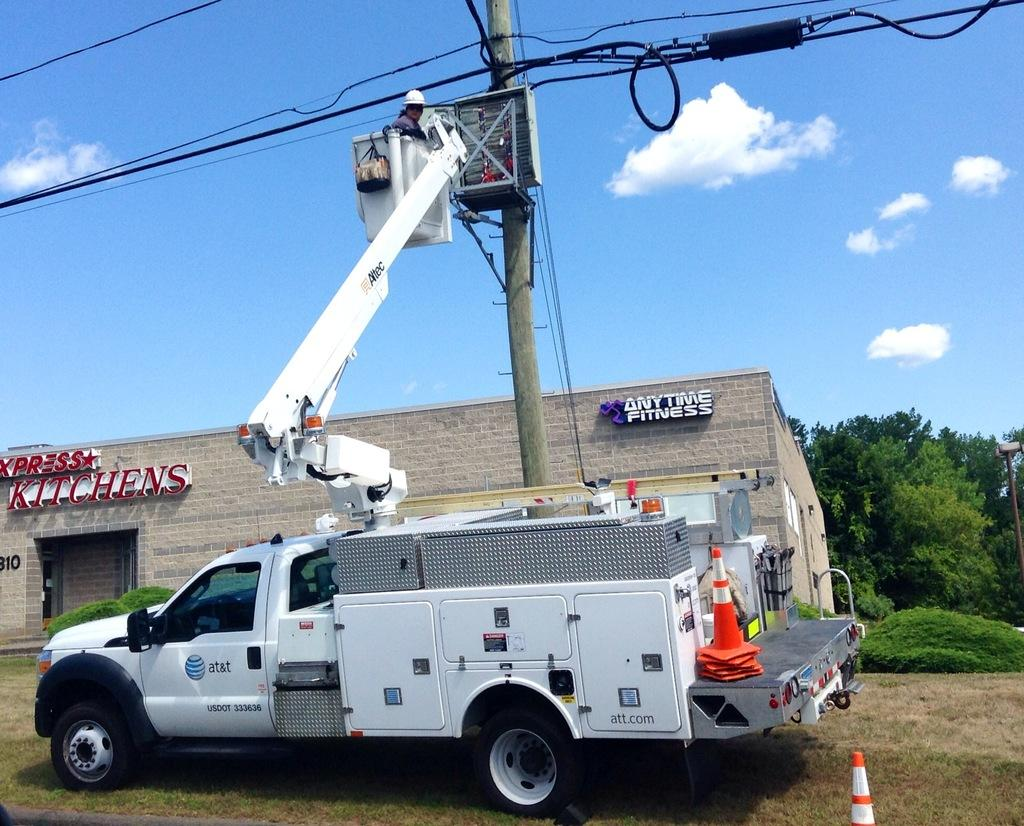What type of machinery is present in the image? There is a crane in the image. What other type of vehicle can be seen in the image? There is a vehicle in the image. What natural elements are visible in the image? There are trees and grass in the image. What type of structure is present in the image? There is a house with some text in the image. How much sand is being crushed by the crane in the image? There is no sand or crushing activity present in the image. What color is the silver object in the image? There is no silver object present in the image. 